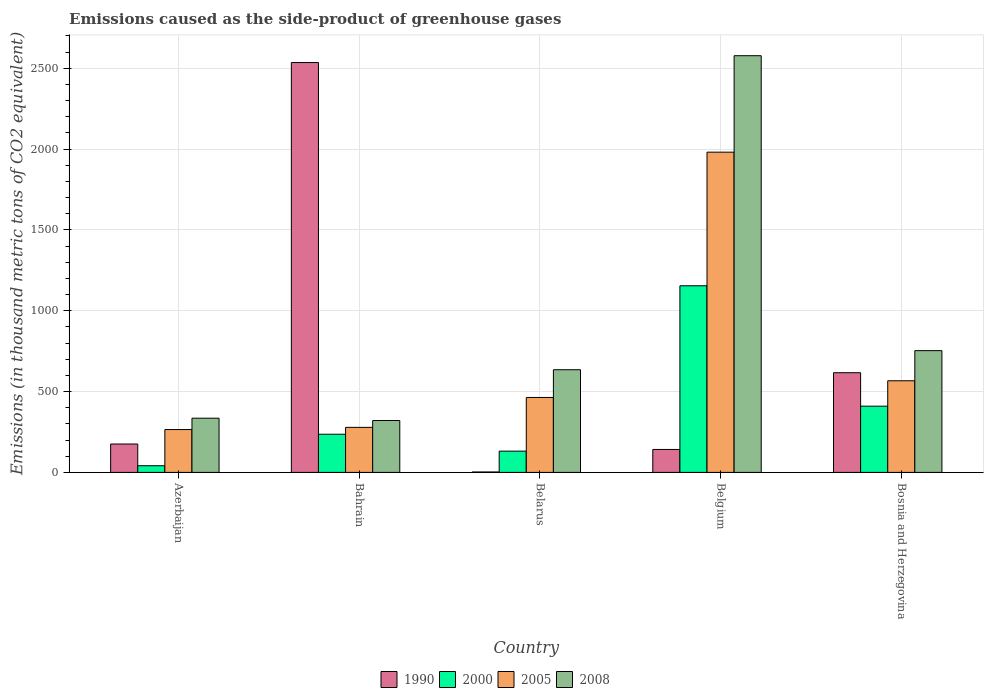How many different coloured bars are there?
Provide a short and direct response. 4. How many groups of bars are there?
Give a very brief answer. 5. How many bars are there on the 5th tick from the right?
Offer a terse response. 4. What is the label of the 4th group of bars from the left?
Make the answer very short. Belgium. What is the emissions caused as the side-product of greenhouse gases in 2005 in Bahrain?
Provide a short and direct response. 278.6. Across all countries, what is the maximum emissions caused as the side-product of greenhouse gases in 2000?
Make the answer very short. 1154.6. Across all countries, what is the minimum emissions caused as the side-product of greenhouse gases in 2008?
Provide a succinct answer. 320.9. In which country was the emissions caused as the side-product of greenhouse gases in 2005 maximum?
Keep it short and to the point. Belgium. In which country was the emissions caused as the side-product of greenhouse gases in 2005 minimum?
Offer a very short reply. Azerbaijan. What is the total emissions caused as the side-product of greenhouse gases in 2008 in the graph?
Provide a succinct answer. 4622.6. What is the difference between the emissions caused as the side-product of greenhouse gases in 2000 in Belgium and that in Bosnia and Herzegovina?
Offer a very short reply. 744.9. What is the difference between the emissions caused as the side-product of greenhouse gases in 2000 in Bosnia and Herzegovina and the emissions caused as the side-product of greenhouse gases in 1990 in Belgium?
Keep it short and to the point. 267.8. What is the average emissions caused as the side-product of greenhouse gases in 2000 per country?
Keep it short and to the point. 394.66. What is the difference between the emissions caused as the side-product of greenhouse gases of/in 1990 and emissions caused as the side-product of greenhouse gases of/in 2005 in Bosnia and Herzegovina?
Your answer should be very brief. 49.8. What is the ratio of the emissions caused as the side-product of greenhouse gases in 2005 in Azerbaijan to that in Bosnia and Herzegovina?
Make the answer very short. 0.47. Is the emissions caused as the side-product of greenhouse gases in 2005 in Belarus less than that in Belgium?
Your answer should be compact. Yes. What is the difference between the highest and the second highest emissions caused as the side-product of greenhouse gases in 2008?
Ensure brevity in your answer.  -1824.8. What is the difference between the highest and the lowest emissions caused as the side-product of greenhouse gases in 2005?
Your response must be concise. 1716.1. Is the sum of the emissions caused as the side-product of greenhouse gases in 1990 in Belgium and Bosnia and Herzegovina greater than the maximum emissions caused as the side-product of greenhouse gases in 2008 across all countries?
Provide a succinct answer. No. Is it the case that in every country, the sum of the emissions caused as the side-product of greenhouse gases in 2008 and emissions caused as the side-product of greenhouse gases in 2000 is greater than the emissions caused as the side-product of greenhouse gases in 1990?
Provide a short and direct response. No. How many bars are there?
Your answer should be very brief. 20. How many countries are there in the graph?
Your answer should be very brief. 5. What is the difference between two consecutive major ticks on the Y-axis?
Offer a very short reply. 500. Does the graph contain grids?
Ensure brevity in your answer.  Yes. Where does the legend appear in the graph?
Make the answer very short. Bottom center. How many legend labels are there?
Offer a very short reply. 4. How are the legend labels stacked?
Give a very brief answer. Horizontal. What is the title of the graph?
Keep it short and to the point. Emissions caused as the side-product of greenhouse gases. Does "1987" appear as one of the legend labels in the graph?
Ensure brevity in your answer.  No. What is the label or title of the Y-axis?
Your answer should be compact. Emissions (in thousand metric tons of CO2 equivalent). What is the Emissions (in thousand metric tons of CO2 equivalent) of 1990 in Azerbaijan?
Ensure brevity in your answer.  175.6. What is the Emissions (in thousand metric tons of CO2 equivalent) in 2000 in Azerbaijan?
Provide a succinct answer. 41.3. What is the Emissions (in thousand metric tons of CO2 equivalent) in 2005 in Azerbaijan?
Your answer should be compact. 265.1. What is the Emissions (in thousand metric tons of CO2 equivalent) in 2008 in Azerbaijan?
Offer a terse response. 335.3. What is the Emissions (in thousand metric tons of CO2 equivalent) in 1990 in Bahrain?
Provide a succinct answer. 2535.7. What is the Emissions (in thousand metric tons of CO2 equivalent) of 2000 in Bahrain?
Your response must be concise. 236.1. What is the Emissions (in thousand metric tons of CO2 equivalent) of 2005 in Bahrain?
Make the answer very short. 278.6. What is the Emissions (in thousand metric tons of CO2 equivalent) of 2008 in Bahrain?
Your answer should be very brief. 320.9. What is the Emissions (in thousand metric tons of CO2 equivalent) in 2000 in Belarus?
Ensure brevity in your answer.  131.6. What is the Emissions (in thousand metric tons of CO2 equivalent) of 2005 in Belarus?
Your answer should be very brief. 463.6. What is the Emissions (in thousand metric tons of CO2 equivalent) of 2008 in Belarus?
Offer a terse response. 635.2. What is the Emissions (in thousand metric tons of CO2 equivalent) in 1990 in Belgium?
Give a very brief answer. 141.9. What is the Emissions (in thousand metric tons of CO2 equivalent) in 2000 in Belgium?
Keep it short and to the point. 1154.6. What is the Emissions (in thousand metric tons of CO2 equivalent) in 2005 in Belgium?
Offer a very short reply. 1981.2. What is the Emissions (in thousand metric tons of CO2 equivalent) of 2008 in Belgium?
Make the answer very short. 2578. What is the Emissions (in thousand metric tons of CO2 equivalent) of 1990 in Bosnia and Herzegovina?
Your answer should be very brief. 616.7. What is the Emissions (in thousand metric tons of CO2 equivalent) of 2000 in Bosnia and Herzegovina?
Provide a succinct answer. 409.7. What is the Emissions (in thousand metric tons of CO2 equivalent) in 2005 in Bosnia and Herzegovina?
Your response must be concise. 566.9. What is the Emissions (in thousand metric tons of CO2 equivalent) in 2008 in Bosnia and Herzegovina?
Offer a terse response. 753.2. Across all countries, what is the maximum Emissions (in thousand metric tons of CO2 equivalent) of 1990?
Your response must be concise. 2535.7. Across all countries, what is the maximum Emissions (in thousand metric tons of CO2 equivalent) in 2000?
Ensure brevity in your answer.  1154.6. Across all countries, what is the maximum Emissions (in thousand metric tons of CO2 equivalent) of 2005?
Offer a very short reply. 1981.2. Across all countries, what is the maximum Emissions (in thousand metric tons of CO2 equivalent) in 2008?
Keep it short and to the point. 2578. Across all countries, what is the minimum Emissions (in thousand metric tons of CO2 equivalent) in 1990?
Offer a very short reply. 2.6. Across all countries, what is the minimum Emissions (in thousand metric tons of CO2 equivalent) in 2000?
Offer a terse response. 41.3. Across all countries, what is the minimum Emissions (in thousand metric tons of CO2 equivalent) in 2005?
Offer a terse response. 265.1. Across all countries, what is the minimum Emissions (in thousand metric tons of CO2 equivalent) of 2008?
Your response must be concise. 320.9. What is the total Emissions (in thousand metric tons of CO2 equivalent) of 1990 in the graph?
Offer a terse response. 3472.5. What is the total Emissions (in thousand metric tons of CO2 equivalent) of 2000 in the graph?
Keep it short and to the point. 1973.3. What is the total Emissions (in thousand metric tons of CO2 equivalent) in 2005 in the graph?
Provide a short and direct response. 3555.4. What is the total Emissions (in thousand metric tons of CO2 equivalent) of 2008 in the graph?
Ensure brevity in your answer.  4622.6. What is the difference between the Emissions (in thousand metric tons of CO2 equivalent) of 1990 in Azerbaijan and that in Bahrain?
Your answer should be compact. -2360.1. What is the difference between the Emissions (in thousand metric tons of CO2 equivalent) of 2000 in Azerbaijan and that in Bahrain?
Give a very brief answer. -194.8. What is the difference between the Emissions (in thousand metric tons of CO2 equivalent) of 1990 in Azerbaijan and that in Belarus?
Make the answer very short. 173. What is the difference between the Emissions (in thousand metric tons of CO2 equivalent) in 2000 in Azerbaijan and that in Belarus?
Ensure brevity in your answer.  -90.3. What is the difference between the Emissions (in thousand metric tons of CO2 equivalent) of 2005 in Azerbaijan and that in Belarus?
Provide a short and direct response. -198.5. What is the difference between the Emissions (in thousand metric tons of CO2 equivalent) of 2008 in Azerbaijan and that in Belarus?
Your answer should be very brief. -299.9. What is the difference between the Emissions (in thousand metric tons of CO2 equivalent) in 1990 in Azerbaijan and that in Belgium?
Your response must be concise. 33.7. What is the difference between the Emissions (in thousand metric tons of CO2 equivalent) in 2000 in Azerbaijan and that in Belgium?
Your response must be concise. -1113.3. What is the difference between the Emissions (in thousand metric tons of CO2 equivalent) in 2005 in Azerbaijan and that in Belgium?
Provide a succinct answer. -1716.1. What is the difference between the Emissions (in thousand metric tons of CO2 equivalent) of 2008 in Azerbaijan and that in Belgium?
Offer a terse response. -2242.7. What is the difference between the Emissions (in thousand metric tons of CO2 equivalent) of 1990 in Azerbaijan and that in Bosnia and Herzegovina?
Keep it short and to the point. -441.1. What is the difference between the Emissions (in thousand metric tons of CO2 equivalent) in 2000 in Azerbaijan and that in Bosnia and Herzegovina?
Your response must be concise. -368.4. What is the difference between the Emissions (in thousand metric tons of CO2 equivalent) of 2005 in Azerbaijan and that in Bosnia and Herzegovina?
Provide a succinct answer. -301.8. What is the difference between the Emissions (in thousand metric tons of CO2 equivalent) of 2008 in Azerbaijan and that in Bosnia and Herzegovina?
Give a very brief answer. -417.9. What is the difference between the Emissions (in thousand metric tons of CO2 equivalent) of 1990 in Bahrain and that in Belarus?
Give a very brief answer. 2533.1. What is the difference between the Emissions (in thousand metric tons of CO2 equivalent) in 2000 in Bahrain and that in Belarus?
Keep it short and to the point. 104.5. What is the difference between the Emissions (in thousand metric tons of CO2 equivalent) of 2005 in Bahrain and that in Belarus?
Give a very brief answer. -185. What is the difference between the Emissions (in thousand metric tons of CO2 equivalent) of 2008 in Bahrain and that in Belarus?
Your answer should be compact. -314.3. What is the difference between the Emissions (in thousand metric tons of CO2 equivalent) in 1990 in Bahrain and that in Belgium?
Provide a short and direct response. 2393.8. What is the difference between the Emissions (in thousand metric tons of CO2 equivalent) of 2000 in Bahrain and that in Belgium?
Keep it short and to the point. -918.5. What is the difference between the Emissions (in thousand metric tons of CO2 equivalent) in 2005 in Bahrain and that in Belgium?
Offer a terse response. -1702.6. What is the difference between the Emissions (in thousand metric tons of CO2 equivalent) in 2008 in Bahrain and that in Belgium?
Provide a succinct answer. -2257.1. What is the difference between the Emissions (in thousand metric tons of CO2 equivalent) in 1990 in Bahrain and that in Bosnia and Herzegovina?
Offer a very short reply. 1919. What is the difference between the Emissions (in thousand metric tons of CO2 equivalent) of 2000 in Bahrain and that in Bosnia and Herzegovina?
Make the answer very short. -173.6. What is the difference between the Emissions (in thousand metric tons of CO2 equivalent) in 2005 in Bahrain and that in Bosnia and Herzegovina?
Offer a terse response. -288.3. What is the difference between the Emissions (in thousand metric tons of CO2 equivalent) in 2008 in Bahrain and that in Bosnia and Herzegovina?
Provide a succinct answer. -432.3. What is the difference between the Emissions (in thousand metric tons of CO2 equivalent) of 1990 in Belarus and that in Belgium?
Provide a short and direct response. -139.3. What is the difference between the Emissions (in thousand metric tons of CO2 equivalent) of 2000 in Belarus and that in Belgium?
Your response must be concise. -1023. What is the difference between the Emissions (in thousand metric tons of CO2 equivalent) of 2005 in Belarus and that in Belgium?
Keep it short and to the point. -1517.6. What is the difference between the Emissions (in thousand metric tons of CO2 equivalent) of 2008 in Belarus and that in Belgium?
Provide a short and direct response. -1942.8. What is the difference between the Emissions (in thousand metric tons of CO2 equivalent) of 1990 in Belarus and that in Bosnia and Herzegovina?
Your answer should be compact. -614.1. What is the difference between the Emissions (in thousand metric tons of CO2 equivalent) of 2000 in Belarus and that in Bosnia and Herzegovina?
Keep it short and to the point. -278.1. What is the difference between the Emissions (in thousand metric tons of CO2 equivalent) in 2005 in Belarus and that in Bosnia and Herzegovina?
Keep it short and to the point. -103.3. What is the difference between the Emissions (in thousand metric tons of CO2 equivalent) of 2008 in Belarus and that in Bosnia and Herzegovina?
Provide a succinct answer. -118. What is the difference between the Emissions (in thousand metric tons of CO2 equivalent) in 1990 in Belgium and that in Bosnia and Herzegovina?
Ensure brevity in your answer.  -474.8. What is the difference between the Emissions (in thousand metric tons of CO2 equivalent) of 2000 in Belgium and that in Bosnia and Herzegovina?
Make the answer very short. 744.9. What is the difference between the Emissions (in thousand metric tons of CO2 equivalent) of 2005 in Belgium and that in Bosnia and Herzegovina?
Keep it short and to the point. 1414.3. What is the difference between the Emissions (in thousand metric tons of CO2 equivalent) of 2008 in Belgium and that in Bosnia and Herzegovina?
Offer a very short reply. 1824.8. What is the difference between the Emissions (in thousand metric tons of CO2 equivalent) of 1990 in Azerbaijan and the Emissions (in thousand metric tons of CO2 equivalent) of 2000 in Bahrain?
Ensure brevity in your answer.  -60.5. What is the difference between the Emissions (in thousand metric tons of CO2 equivalent) of 1990 in Azerbaijan and the Emissions (in thousand metric tons of CO2 equivalent) of 2005 in Bahrain?
Ensure brevity in your answer.  -103. What is the difference between the Emissions (in thousand metric tons of CO2 equivalent) in 1990 in Azerbaijan and the Emissions (in thousand metric tons of CO2 equivalent) in 2008 in Bahrain?
Ensure brevity in your answer.  -145.3. What is the difference between the Emissions (in thousand metric tons of CO2 equivalent) in 2000 in Azerbaijan and the Emissions (in thousand metric tons of CO2 equivalent) in 2005 in Bahrain?
Offer a terse response. -237.3. What is the difference between the Emissions (in thousand metric tons of CO2 equivalent) in 2000 in Azerbaijan and the Emissions (in thousand metric tons of CO2 equivalent) in 2008 in Bahrain?
Make the answer very short. -279.6. What is the difference between the Emissions (in thousand metric tons of CO2 equivalent) in 2005 in Azerbaijan and the Emissions (in thousand metric tons of CO2 equivalent) in 2008 in Bahrain?
Provide a short and direct response. -55.8. What is the difference between the Emissions (in thousand metric tons of CO2 equivalent) in 1990 in Azerbaijan and the Emissions (in thousand metric tons of CO2 equivalent) in 2005 in Belarus?
Your answer should be compact. -288. What is the difference between the Emissions (in thousand metric tons of CO2 equivalent) in 1990 in Azerbaijan and the Emissions (in thousand metric tons of CO2 equivalent) in 2008 in Belarus?
Make the answer very short. -459.6. What is the difference between the Emissions (in thousand metric tons of CO2 equivalent) in 2000 in Azerbaijan and the Emissions (in thousand metric tons of CO2 equivalent) in 2005 in Belarus?
Ensure brevity in your answer.  -422.3. What is the difference between the Emissions (in thousand metric tons of CO2 equivalent) in 2000 in Azerbaijan and the Emissions (in thousand metric tons of CO2 equivalent) in 2008 in Belarus?
Your answer should be compact. -593.9. What is the difference between the Emissions (in thousand metric tons of CO2 equivalent) in 2005 in Azerbaijan and the Emissions (in thousand metric tons of CO2 equivalent) in 2008 in Belarus?
Your answer should be very brief. -370.1. What is the difference between the Emissions (in thousand metric tons of CO2 equivalent) of 1990 in Azerbaijan and the Emissions (in thousand metric tons of CO2 equivalent) of 2000 in Belgium?
Give a very brief answer. -979. What is the difference between the Emissions (in thousand metric tons of CO2 equivalent) in 1990 in Azerbaijan and the Emissions (in thousand metric tons of CO2 equivalent) in 2005 in Belgium?
Give a very brief answer. -1805.6. What is the difference between the Emissions (in thousand metric tons of CO2 equivalent) of 1990 in Azerbaijan and the Emissions (in thousand metric tons of CO2 equivalent) of 2008 in Belgium?
Offer a very short reply. -2402.4. What is the difference between the Emissions (in thousand metric tons of CO2 equivalent) of 2000 in Azerbaijan and the Emissions (in thousand metric tons of CO2 equivalent) of 2005 in Belgium?
Provide a short and direct response. -1939.9. What is the difference between the Emissions (in thousand metric tons of CO2 equivalent) of 2000 in Azerbaijan and the Emissions (in thousand metric tons of CO2 equivalent) of 2008 in Belgium?
Provide a succinct answer. -2536.7. What is the difference between the Emissions (in thousand metric tons of CO2 equivalent) in 2005 in Azerbaijan and the Emissions (in thousand metric tons of CO2 equivalent) in 2008 in Belgium?
Provide a succinct answer. -2312.9. What is the difference between the Emissions (in thousand metric tons of CO2 equivalent) of 1990 in Azerbaijan and the Emissions (in thousand metric tons of CO2 equivalent) of 2000 in Bosnia and Herzegovina?
Ensure brevity in your answer.  -234.1. What is the difference between the Emissions (in thousand metric tons of CO2 equivalent) in 1990 in Azerbaijan and the Emissions (in thousand metric tons of CO2 equivalent) in 2005 in Bosnia and Herzegovina?
Keep it short and to the point. -391.3. What is the difference between the Emissions (in thousand metric tons of CO2 equivalent) of 1990 in Azerbaijan and the Emissions (in thousand metric tons of CO2 equivalent) of 2008 in Bosnia and Herzegovina?
Ensure brevity in your answer.  -577.6. What is the difference between the Emissions (in thousand metric tons of CO2 equivalent) of 2000 in Azerbaijan and the Emissions (in thousand metric tons of CO2 equivalent) of 2005 in Bosnia and Herzegovina?
Provide a succinct answer. -525.6. What is the difference between the Emissions (in thousand metric tons of CO2 equivalent) in 2000 in Azerbaijan and the Emissions (in thousand metric tons of CO2 equivalent) in 2008 in Bosnia and Herzegovina?
Make the answer very short. -711.9. What is the difference between the Emissions (in thousand metric tons of CO2 equivalent) in 2005 in Azerbaijan and the Emissions (in thousand metric tons of CO2 equivalent) in 2008 in Bosnia and Herzegovina?
Provide a short and direct response. -488.1. What is the difference between the Emissions (in thousand metric tons of CO2 equivalent) in 1990 in Bahrain and the Emissions (in thousand metric tons of CO2 equivalent) in 2000 in Belarus?
Offer a very short reply. 2404.1. What is the difference between the Emissions (in thousand metric tons of CO2 equivalent) in 1990 in Bahrain and the Emissions (in thousand metric tons of CO2 equivalent) in 2005 in Belarus?
Offer a very short reply. 2072.1. What is the difference between the Emissions (in thousand metric tons of CO2 equivalent) in 1990 in Bahrain and the Emissions (in thousand metric tons of CO2 equivalent) in 2008 in Belarus?
Ensure brevity in your answer.  1900.5. What is the difference between the Emissions (in thousand metric tons of CO2 equivalent) in 2000 in Bahrain and the Emissions (in thousand metric tons of CO2 equivalent) in 2005 in Belarus?
Your answer should be compact. -227.5. What is the difference between the Emissions (in thousand metric tons of CO2 equivalent) in 2000 in Bahrain and the Emissions (in thousand metric tons of CO2 equivalent) in 2008 in Belarus?
Ensure brevity in your answer.  -399.1. What is the difference between the Emissions (in thousand metric tons of CO2 equivalent) of 2005 in Bahrain and the Emissions (in thousand metric tons of CO2 equivalent) of 2008 in Belarus?
Offer a terse response. -356.6. What is the difference between the Emissions (in thousand metric tons of CO2 equivalent) of 1990 in Bahrain and the Emissions (in thousand metric tons of CO2 equivalent) of 2000 in Belgium?
Your answer should be compact. 1381.1. What is the difference between the Emissions (in thousand metric tons of CO2 equivalent) of 1990 in Bahrain and the Emissions (in thousand metric tons of CO2 equivalent) of 2005 in Belgium?
Offer a terse response. 554.5. What is the difference between the Emissions (in thousand metric tons of CO2 equivalent) in 1990 in Bahrain and the Emissions (in thousand metric tons of CO2 equivalent) in 2008 in Belgium?
Your answer should be compact. -42.3. What is the difference between the Emissions (in thousand metric tons of CO2 equivalent) of 2000 in Bahrain and the Emissions (in thousand metric tons of CO2 equivalent) of 2005 in Belgium?
Your answer should be very brief. -1745.1. What is the difference between the Emissions (in thousand metric tons of CO2 equivalent) in 2000 in Bahrain and the Emissions (in thousand metric tons of CO2 equivalent) in 2008 in Belgium?
Your answer should be compact. -2341.9. What is the difference between the Emissions (in thousand metric tons of CO2 equivalent) in 2005 in Bahrain and the Emissions (in thousand metric tons of CO2 equivalent) in 2008 in Belgium?
Provide a short and direct response. -2299.4. What is the difference between the Emissions (in thousand metric tons of CO2 equivalent) of 1990 in Bahrain and the Emissions (in thousand metric tons of CO2 equivalent) of 2000 in Bosnia and Herzegovina?
Offer a very short reply. 2126. What is the difference between the Emissions (in thousand metric tons of CO2 equivalent) of 1990 in Bahrain and the Emissions (in thousand metric tons of CO2 equivalent) of 2005 in Bosnia and Herzegovina?
Provide a short and direct response. 1968.8. What is the difference between the Emissions (in thousand metric tons of CO2 equivalent) of 1990 in Bahrain and the Emissions (in thousand metric tons of CO2 equivalent) of 2008 in Bosnia and Herzegovina?
Give a very brief answer. 1782.5. What is the difference between the Emissions (in thousand metric tons of CO2 equivalent) of 2000 in Bahrain and the Emissions (in thousand metric tons of CO2 equivalent) of 2005 in Bosnia and Herzegovina?
Ensure brevity in your answer.  -330.8. What is the difference between the Emissions (in thousand metric tons of CO2 equivalent) in 2000 in Bahrain and the Emissions (in thousand metric tons of CO2 equivalent) in 2008 in Bosnia and Herzegovina?
Provide a succinct answer. -517.1. What is the difference between the Emissions (in thousand metric tons of CO2 equivalent) of 2005 in Bahrain and the Emissions (in thousand metric tons of CO2 equivalent) of 2008 in Bosnia and Herzegovina?
Keep it short and to the point. -474.6. What is the difference between the Emissions (in thousand metric tons of CO2 equivalent) of 1990 in Belarus and the Emissions (in thousand metric tons of CO2 equivalent) of 2000 in Belgium?
Give a very brief answer. -1152. What is the difference between the Emissions (in thousand metric tons of CO2 equivalent) in 1990 in Belarus and the Emissions (in thousand metric tons of CO2 equivalent) in 2005 in Belgium?
Offer a terse response. -1978.6. What is the difference between the Emissions (in thousand metric tons of CO2 equivalent) in 1990 in Belarus and the Emissions (in thousand metric tons of CO2 equivalent) in 2008 in Belgium?
Your answer should be compact. -2575.4. What is the difference between the Emissions (in thousand metric tons of CO2 equivalent) in 2000 in Belarus and the Emissions (in thousand metric tons of CO2 equivalent) in 2005 in Belgium?
Your response must be concise. -1849.6. What is the difference between the Emissions (in thousand metric tons of CO2 equivalent) of 2000 in Belarus and the Emissions (in thousand metric tons of CO2 equivalent) of 2008 in Belgium?
Offer a terse response. -2446.4. What is the difference between the Emissions (in thousand metric tons of CO2 equivalent) of 2005 in Belarus and the Emissions (in thousand metric tons of CO2 equivalent) of 2008 in Belgium?
Offer a terse response. -2114.4. What is the difference between the Emissions (in thousand metric tons of CO2 equivalent) in 1990 in Belarus and the Emissions (in thousand metric tons of CO2 equivalent) in 2000 in Bosnia and Herzegovina?
Your answer should be compact. -407.1. What is the difference between the Emissions (in thousand metric tons of CO2 equivalent) of 1990 in Belarus and the Emissions (in thousand metric tons of CO2 equivalent) of 2005 in Bosnia and Herzegovina?
Your answer should be very brief. -564.3. What is the difference between the Emissions (in thousand metric tons of CO2 equivalent) of 1990 in Belarus and the Emissions (in thousand metric tons of CO2 equivalent) of 2008 in Bosnia and Herzegovina?
Give a very brief answer. -750.6. What is the difference between the Emissions (in thousand metric tons of CO2 equivalent) in 2000 in Belarus and the Emissions (in thousand metric tons of CO2 equivalent) in 2005 in Bosnia and Herzegovina?
Your answer should be very brief. -435.3. What is the difference between the Emissions (in thousand metric tons of CO2 equivalent) in 2000 in Belarus and the Emissions (in thousand metric tons of CO2 equivalent) in 2008 in Bosnia and Herzegovina?
Provide a succinct answer. -621.6. What is the difference between the Emissions (in thousand metric tons of CO2 equivalent) in 2005 in Belarus and the Emissions (in thousand metric tons of CO2 equivalent) in 2008 in Bosnia and Herzegovina?
Ensure brevity in your answer.  -289.6. What is the difference between the Emissions (in thousand metric tons of CO2 equivalent) of 1990 in Belgium and the Emissions (in thousand metric tons of CO2 equivalent) of 2000 in Bosnia and Herzegovina?
Your response must be concise. -267.8. What is the difference between the Emissions (in thousand metric tons of CO2 equivalent) of 1990 in Belgium and the Emissions (in thousand metric tons of CO2 equivalent) of 2005 in Bosnia and Herzegovina?
Make the answer very short. -425. What is the difference between the Emissions (in thousand metric tons of CO2 equivalent) in 1990 in Belgium and the Emissions (in thousand metric tons of CO2 equivalent) in 2008 in Bosnia and Herzegovina?
Your answer should be very brief. -611.3. What is the difference between the Emissions (in thousand metric tons of CO2 equivalent) in 2000 in Belgium and the Emissions (in thousand metric tons of CO2 equivalent) in 2005 in Bosnia and Herzegovina?
Give a very brief answer. 587.7. What is the difference between the Emissions (in thousand metric tons of CO2 equivalent) of 2000 in Belgium and the Emissions (in thousand metric tons of CO2 equivalent) of 2008 in Bosnia and Herzegovina?
Provide a succinct answer. 401.4. What is the difference between the Emissions (in thousand metric tons of CO2 equivalent) of 2005 in Belgium and the Emissions (in thousand metric tons of CO2 equivalent) of 2008 in Bosnia and Herzegovina?
Keep it short and to the point. 1228. What is the average Emissions (in thousand metric tons of CO2 equivalent) of 1990 per country?
Your answer should be compact. 694.5. What is the average Emissions (in thousand metric tons of CO2 equivalent) of 2000 per country?
Your response must be concise. 394.66. What is the average Emissions (in thousand metric tons of CO2 equivalent) in 2005 per country?
Provide a short and direct response. 711.08. What is the average Emissions (in thousand metric tons of CO2 equivalent) of 2008 per country?
Your answer should be very brief. 924.52. What is the difference between the Emissions (in thousand metric tons of CO2 equivalent) of 1990 and Emissions (in thousand metric tons of CO2 equivalent) of 2000 in Azerbaijan?
Keep it short and to the point. 134.3. What is the difference between the Emissions (in thousand metric tons of CO2 equivalent) of 1990 and Emissions (in thousand metric tons of CO2 equivalent) of 2005 in Azerbaijan?
Give a very brief answer. -89.5. What is the difference between the Emissions (in thousand metric tons of CO2 equivalent) in 1990 and Emissions (in thousand metric tons of CO2 equivalent) in 2008 in Azerbaijan?
Offer a terse response. -159.7. What is the difference between the Emissions (in thousand metric tons of CO2 equivalent) of 2000 and Emissions (in thousand metric tons of CO2 equivalent) of 2005 in Azerbaijan?
Make the answer very short. -223.8. What is the difference between the Emissions (in thousand metric tons of CO2 equivalent) in 2000 and Emissions (in thousand metric tons of CO2 equivalent) in 2008 in Azerbaijan?
Provide a short and direct response. -294. What is the difference between the Emissions (in thousand metric tons of CO2 equivalent) of 2005 and Emissions (in thousand metric tons of CO2 equivalent) of 2008 in Azerbaijan?
Keep it short and to the point. -70.2. What is the difference between the Emissions (in thousand metric tons of CO2 equivalent) in 1990 and Emissions (in thousand metric tons of CO2 equivalent) in 2000 in Bahrain?
Your answer should be compact. 2299.6. What is the difference between the Emissions (in thousand metric tons of CO2 equivalent) of 1990 and Emissions (in thousand metric tons of CO2 equivalent) of 2005 in Bahrain?
Offer a very short reply. 2257.1. What is the difference between the Emissions (in thousand metric tons of CO2 equivalent) in 1990 and Emissions (in thousand metric tons of CO2 equivalent) in 2008 in Bahrain?
Give a very brief answer. 2214.8. What is the difference between the Emissions (in thousand metric tons of CO2 equivalent) in 2000 and Emissions (in thousand metric tons of CO2 equivalent) in 2005 in Bahrain?
Provide a short and direct response. -42.5. What is the difference between the Emissions (in thousand metric tons of CO2 equivalent) of 2000 and Emissions (in thousand metric tons of CO2 equivalent) of 2008 in Bahrain?
Make the answer very short. -84.8. What is the difference between the Emissions (in thousand metric tons of CO2 equivalent) in 2005 and Emissions (in thousand metric tons of CO2 equivalent) in 2008 in Bahrain?
Provide a short and direct response. -42.3. What is the difference between the Emissions (in thousand metric tons of CO2 equivalent) in 1990 and Emissions (in thousand metric tons of CO2 equivalent) in 2000 in Belarus?
Your answer should be very brief. -129. What is the difference between the Emissions (in thousand metric tons of CO2 equivalent) in 1990 and Emissions (in thousand metric tons of CO2 equivalent) in 2005 in Belarus?
Ensure brevity in your answer.  -461. What is the difference between the Emissions (in thousand metric tons of CO2 equivalent) of 1990 and Emissions (in thousand metric tons of CO2 equivalent) of 2008 in Belarus?
Your answer should be very brief. -632.6. What is the difference between the Emissions (in thousand metric tons of CO2 equivalent) in 2000 and Emissions (in thousand metric tons of CO2 equivalent) in 2005 in Belarus?
Provide a short and direct response. -332. What is the difference between the Emissions (in thousand metric tons of CO2 equivalent) of 2000 and Emissions (in thousand metric tons of CO2 equivalent) of 2008 in Belarus?
Provide a short and direct response. -503.6. What is the difference between the Emissions (in thousand metric tons of CO2 equivalent) in 2005 and Emissions (in thousand metric tons of CO2 equivalent) in 2008 in Belarus?
Provide a short and direct response. -171.6. What is the difference between the Emissions (in thousand metric tons of CO2 equivalent) of 1990 and Emissions (in thousand metric tons of CO2 equivalent) of 2000 in Belgium?
Give a very brief answer. -1012.7. What is the difference between the Emissions (in thousand metric tons of CO2 equivalent) in 1990 and Emissions (in thousand metric tons of CO2 equivalent) in 2005 in Belgium?
Offer a very short reply. -1839.3. What is the difference between the Emissions (in thousand metric tons of CO2 equivalent) in 1990 and Emissions (in thousand metric tons of CO2 equivalent) in 2008 in Belgium?
Your answer should be very brief. -2436.1. What is the difference between the Emissions (in thousand metric tons of CO2 equivalent) of 2000 and Emissions (in thousand metric tons of CO2 equivalent) of 2005 in Belgium?
Provide a succinct answer. -826.6. What is the difference between the Emissions (in thousand metric tons of CO2 equivalent) of 2000 and Emissions (in thousand metric tons of CO2 equivalent) of 2008 in Belgium?
Your answer should be compact. -1423.4. What is the difference between the Emissions (in thousand metric tons of CO2 equivalent) of 2005 and Emissions (in thousand metric tons of CO2 equivalent) of 2008 in Belgium?
Offer a terse response. -596.8. What is the difference between the Emissions (in thousand metric tons of CO2 equivalent) of 1990 and Emissions (in thousand metric tons of CO2 equivalent) of 2000 in Bosnia and Herzegovina?
Offer a very short reply. 207. What is the difference between the Emissions (in thousand metric tons of CO2 equivalent) of 1990 and Emissions (in thousand metric tons of CO2 equivalent) of 2005 in Bosnia and Herzegovina?
Keep it short and to the point. 49.8. What is the difference between the Emissions (in thousand metric tons of CO2 equivalent) of 1990 and Emissions (in thousand metric tons of CO2 equivalent) of 2008 in Bosnia and Herzegovina?
Your answer should be very brief. -136.5. What is the difference between the Emissions (in thousand metric tons of CO2 equivalent) of 2000 and Emissions (in thousand metric tons of CO2 equivalent) of 2005 in Bosnia and Herzegovina?
Keep it short and to the point. -157.2. What is the difference between the Emissions (in thousand metric tons of CO2 equivalent) in 2000 and Emissions (in thousand metric tons of CO2 equivalent) in 2008 in Bosnia and Herzegovina?
Provide a short and direct response. -343.5. What is the difference between the Emissions (in thousand metric tons of CO2 equivalent) in 2005 and Emissions (in thousand metric tons of CO2 equivalent) in 2008 in Bosnia and Herzegovina?
Make the answer very short. -186.3. What is the ratio of the Emissions (in thousand metric tons of CO2 equivalent) of 1990 in Azerbaijan to that in Bahrain?
Keep it short and to the point. 0.07. What is the ratio of the Emissions (in thousand metric tons of CO2 equivalent) of 2000 in Azerbaijan to that in Bahrain?
Your response must be concise. 0.17. What is the ratio of the Emissions (in thousand metric tons of CO2 equivalent) of 2005 in Azerbaijan to that in Bahrain?
Make the answer very short. 0.95. What is the ratio of the Emissions (in thousand metric tons of CO2 equivalent) in 2008 in Azerbaijan to that in Bahrain?
Your answer should be compact. 1.04. What is the ratio of the Emissions (in thousand metric tons of CO2 equivalent) in 1990 in Azerbaijan to that in Belarus?
Ensure brevity in your answer.  67.54. What is the ratio of the Emissions (in thousand metric tons of CO2 equivalent) in 2000 in Azerbaijan to that in Belarus?
Ensure brevity in your answer.  0.31. What is the ratio of the Emissions (in thousand metric tons of CO2 equivalent) of 2005 in Azerbaijan to that in Belarus?
Make the answer very short. 0.57. What is the ratio of the Emissions (in thousand metric tons of CO2 equivalent) in 2008 in Azerbaijan to that in Belarus?
Make the answer very short. 0.53. What is the ratio of the Emissions (in thousand metric tons of CO2 equivalent) of 1990 in Azerbaijan to that in Belgium?
Your answer should be compact. 1.24. What is the ratio of the Emissions (in thousand metric tons of CO2 equivalent) of 2000 in Azerbaijan to that in Belgium?
Make the answer very short. 0.04. What is the ratio of the Emissions (in thousand metric tons of CO2 equivalent) in 2005 in Azerbaijan to that in Belgium?
Give a very brief answer. 0.13. What is the ratio of the Emissions (in thousand metric tons of CO2 equivalent) of 2008 in Azerbaijan to that in Belgium?
Your answer should be compact. 0.13. What is the ratio of the Emissions (in thousand metric tons of CO2 equivalent) of 1990 in Azerbaijan to that in Bosnia and Herzegovina?
Give a very brief answer. 0.28. What is the ratio of the Emissions (in thousand metric tons of CO2 equivalent) of 2000 in Azerbaijan to that in Bosnia and Herzegovina?
Your answer should be compact. 0.1. What is the ratio of the Emissions (in thousand metric tons of CO2 equivalent) in 2005 in Azerbaijan to that in Bosnia and Herzegovina?
Ensure brevity in your answer.  0.47. What is the ratio of the Emissions (in thousand metric tons of CO2 equivalent) of 2008 in Azerbaijan to that in Bosnia and Herzegovina?
Provide a short and direct response. 0.45. What is the ratio of the Emissions (in thousand metric tons of CO2 equivalent) in 1990 in Bahrain to that in Belarus?
Keep it short and to the point. 975.27. What is the ratio of the Emissions (in thousand metric tons of CO2 equivalent) in 2000 in Bahrain to that in Belarus?
Provide a short and direct response. 1.79. What is the ratio of the Emissions (in thousand metric tons of CO2 equivalent) of 2005 in Bahrain to that in Belarus?
Provide a succinct answer. 0.6. What is the ratio of the Emissions (in thousand metric tons of CO2 equivalent) of 2008 in Bahrain to that in Belarus?
Provide a succinct answer. 0.51. What is the ratio of the Emissions (in thousand metric tons of CO2 equivalent) of 1990 in Bahrain to that in Belgium?
Provide a short and direct response. 17.87. What is the ratio of the Emissions (in thousand metric tons of CO2 equivalent) of 2000 in Bahrain to that in Belgium?
Offer a very short reply. 0.2. What is the ratio of the Emissions (in thousand metric tons of CO2 equivalent) in 2005 in Bahrain to that in Belgium?
Offer a very short reply. 0.14. What is the ratio of the Emissions (in thousand metric tons of CO2 equivalent) of 2008 in Bahrain to that in Belgium?
Offer a terse response. 0.12. What is the ratio of the Emissions (in thousand metric tons of CO2 equivalent) of 1990 in Bahrain to that in Bosnia and Herzegovina?
Your answer should be compact. 4.11. What is the ratio of the Emissions (in thousand metric tons of CO2 equivalent) in 2000 in Bahrain to that in Bosnia and Herzegovina?
Give a very brief answer. 0.58. What is the ratio of the Emissions (in thousand metric tons of CO2 equivalent) of 2005 in Bahrain to that in Bosnia and Herzegovina?
Offer a very short reply. 0.49. What is the ratio of the Emissions (in thousand metric tons of CO2 equivalent) in 2008 in Bahrain to that in Bosnia and Herzegovina?
Ensure brevity in your answer.  0.43. What is the ratio of the Emissions (in thousand metric tons of CO2 equivalent) of 1990 in Belarus to that in Belgium?
Your response must be concise. 0.02. What is the ratio of the Emissions (in thousand metric tons of CO2 equivalent) in 2000 in Belarus to that in Belgium?
Your answer should be very brief. 0.11. What is the ratio of the Emissions (in thousand metric tons of CO2 equivalent) in 2005 in Belarus to that in Belgium?
Ensure brevity in your answer.  0.23. What is the ratio of the Emissions (in thousand metric tons of CO2 equivalent) in 2008 in Belarus to that in Belgium?
Your answer should be very brief. 0.25. What is the ratio of the Emissions (in thousand metric tons of CO2 equivalent) of 1990 in Belarus to that in Bosnia and Herzegovina?
Give a very brief answer. 0. What is the ratio of the Emissions (in thousand metric tons of CO2 equivalent) of 2000 in Belarus to that in Bosnia and Herzegovina?
Your response must be concise. 0.32. What is the ratio of the Emissions (in thousand metric tons of CO2 equivalent) of 2005 in Belarus to that in Bosnia and Herzegovina?
Offer a very short reply. 0.82. What is the ratio of the Emissions (in thousand metric tons of CO2 equivalent) of 2008 in Belarus to that in Bosnia and Herzegovina?
Provide a succinct answer. 0.84. What is the ratio of the Emissions (in thousand metric tons of CO2 equivalent) in 1990 in Belgium to that in Bosnia and Herzegovina?
Offer a very short reply. 0.23. What is the ratio of the Emissions (in thousand metric tons of CO2 equivalent) in 2000 in Belgium to that in Bosnia and Herzegovina?
Offer a very short reply. 2.82. What is the ratio of the Emissions (in thousand metric tons of CO2 equivalent) of 2005 in Belgium to that in Bosnia and Herzegovina?
Your answer should be very brief. 3.49. What is the ratio of the Emissions (in thousand metric tons of CO2 equivalent) of 2008 in Belgium to that in Bosnia and Herzegovina?
Your response must be concise. 3.42. What is the difference between the highest and the second highest Emissions (in thousand metric tons of CO2 equivalent) of 1990?
Give a very brief answer. 1919. What is the difference between the highest and the second highest Emissions (in thousand metric tons of CO2 equivalent) of 2000?
Provide a succinct answer. 744.9. What is the difference between the highest and the second highest Emissions (in thousand metric tons of CO2 equivalent) in 2005?
Ensure brevity in your answer.  1414.3. What is the difference between the highest and the second highest Emissions (in thousand metric tons of CO2 equivalent) in 2008?
Give a very brief answer. 1824.8. What is the difference between the highest and the lowest Emissions (in thousand metric tons of CO2 equivalent) in 1990?
Offer a very short reply. 2533.1. What is the difference between the highest and the lowest Emissions (in thousand metric tons of CO2 equivalent) in 2000?
Ensure brevity in your answer.  1113.3. What is the difference between the highest and the lowest Emissions (in thousand metric tons of CO2 equivalent) in 2005?
Keep it short and to the point. 1716.1. What is the difference between the highest and the lowest Emissions (in thousand metric tons of CO2 equivalent) in 2008?
Keep it short and to the point. 2257.1. 